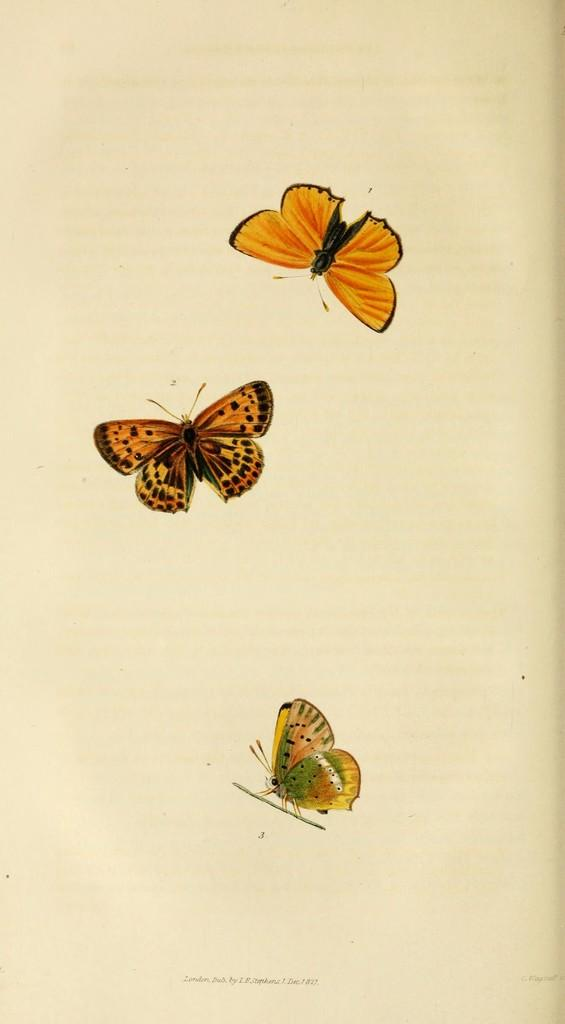What is the main subject in the center of the image? There is a paper in the center of the image. What is on the paper? There are three butterflies on the paper. Is there any text on the paper? Yes, there is text on the paper. Can you see any fish swimming in the background of the image? There are no fish present in the image; it features a paper with butterflies and text. 